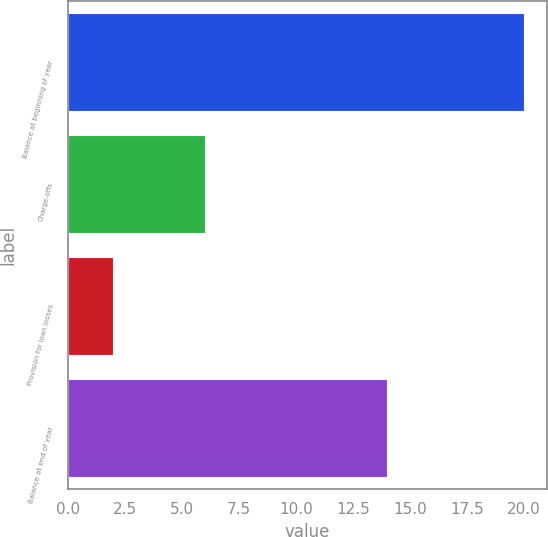Convert chart. <chart><loc_0><loc_0><loc_500><loc_500><bar_chart><fcel>Balance at beginning of year<fcel>Charge-offs<fcel>Provision for loan losses<fcel>Balance at end of year<nl><fcel>20<fcel>6<fcel>2<fcel>14<nl></chart> 